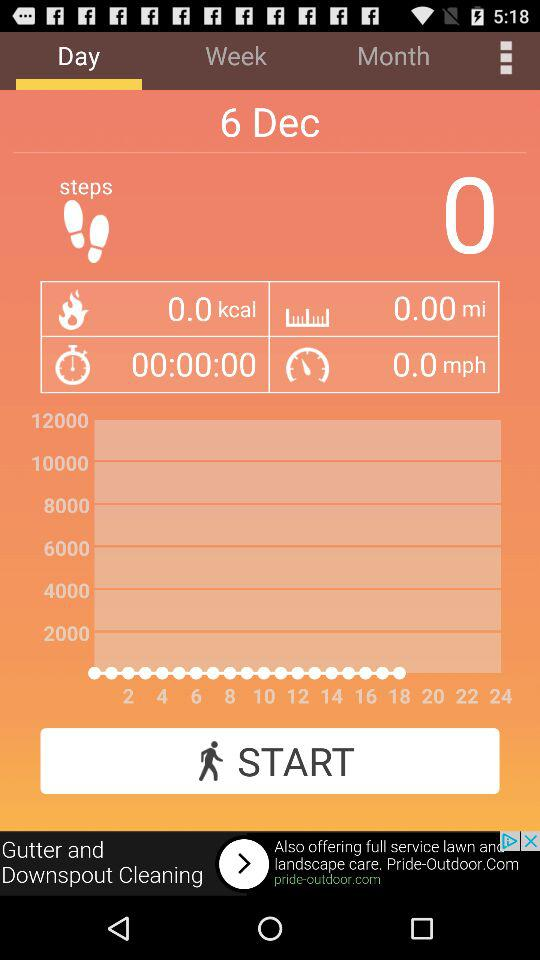Which tab is currently selected? The selected tab is "Day". 